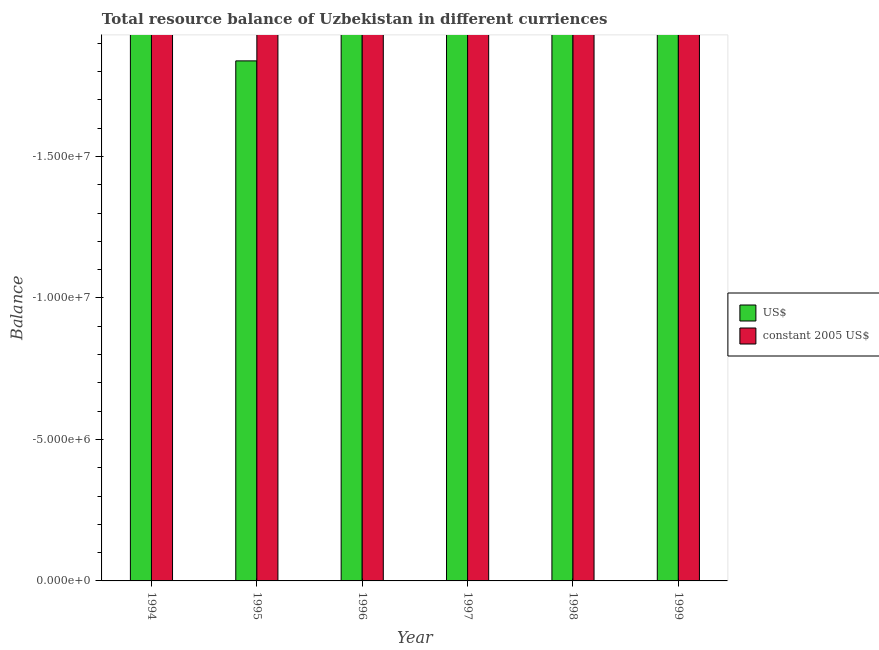Are the number of bars per tick equal to the number of legend labels?
Your answer should be very brief. No. Are the number of bars on each tick of the X-axis equal?
Your answer should be very brief. Yes. How many bars are there on the 2nd tick from the left?
Your answer should be very brief. 0. What is the resource balance in constant us$ in 1994?
Provide a short and direct response. 0. In how many years, is the resource balance in us$ greater than -2000000 units?
Provide a succinct answer. 0. In how many years, is the resource balance in constant us$ greater than the average resource balance in constant us$ taken over all years?
Make the answer very short. 0. How many bars are there?
Offer a very short reply. 0. Are all the bars in the graph horizontal?
Keep it short and to the point. No. How many years are there in the graph?
Ensure brevity in your answer.  6. Are the values on the major ticks of Y-axis written in scientific E-notation?
Give a very brief answer. Yes. Does the graph contain any zero values?
Your answer should be compact. Yes. Where does the legend appear in the graph?
Your answer should be compact. Center right. How are the legend labels stacked?
Ensure brevity in your answer.  Vertical. What is the title of the graph?
Ensure brevity in your answer.  Total resource balance of Uzbekistan in different curriences. Does "2012 US$" appear as one of the legend labels in the graph?
Your response must be concise. No. What is the label or title of the Y-axis?
Ensure brevity in your answer.  Balance. What is the Balance of US$ in 1995?
Your answer should be compact. 0. What is the Balance of constant 2005 US$ in 1995?
Provide a succinct answer. 0. What is the Balance in US$ in 1997?
Your answer should be very brief. 0. What is the Balance of constant 2005 US$ in 1997?
Offer a very short reply. 0. What is the Balance in US$ in 1998?
Give a very brief answer. 0. What is the Balance of constant 2005 US$ in 1998?
Your answer should be very brief. 0. What is the Balance in US$ in 1999?
Your response must be concise. 0. What is the Balance in constant 2005 US$ in 1999?
Give a very brief answer. 0. What is the total Balance of constant 2005 US$ in the graph?
Keep it short and to the point. 0. What is the average Balance of constant 2005 US$ per year?
Provide a succinct answer. 0. 